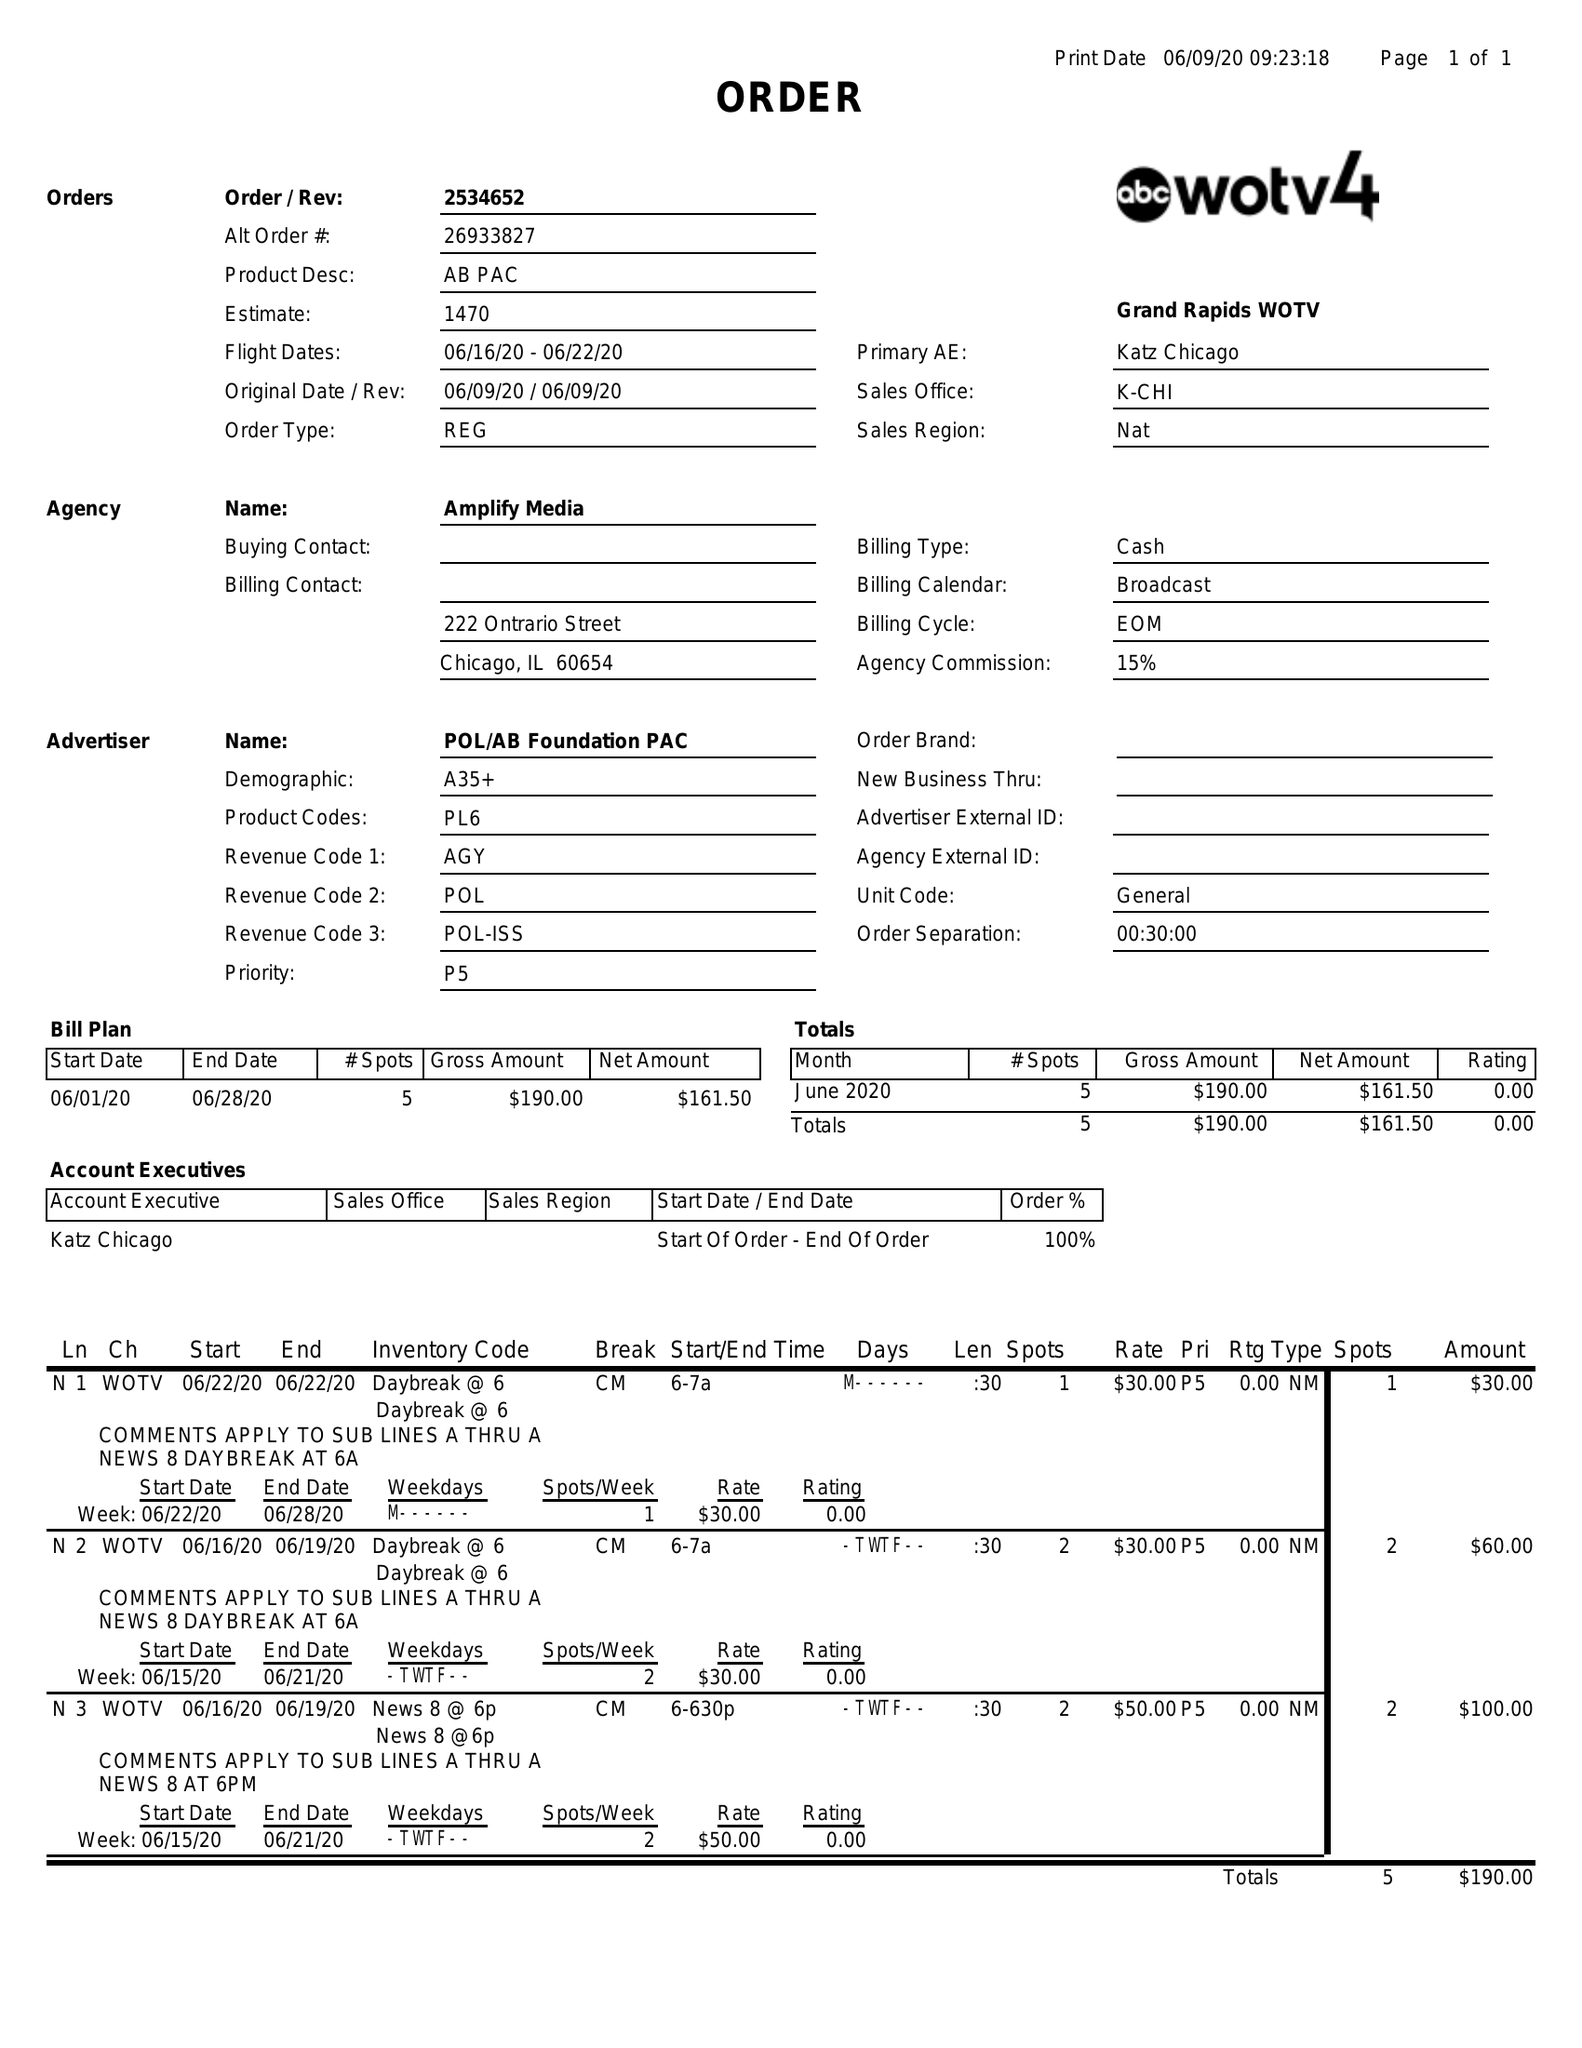What is the value for the flight_from?
Answer the question using a single word or phrase. 06/16/20 